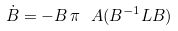<formula> <loc_0><loc_0><loc_500><loc_500>\dot { B } = - B \, \pi _ { \ } A ( B ^ { - 1 } L B )</formula> 